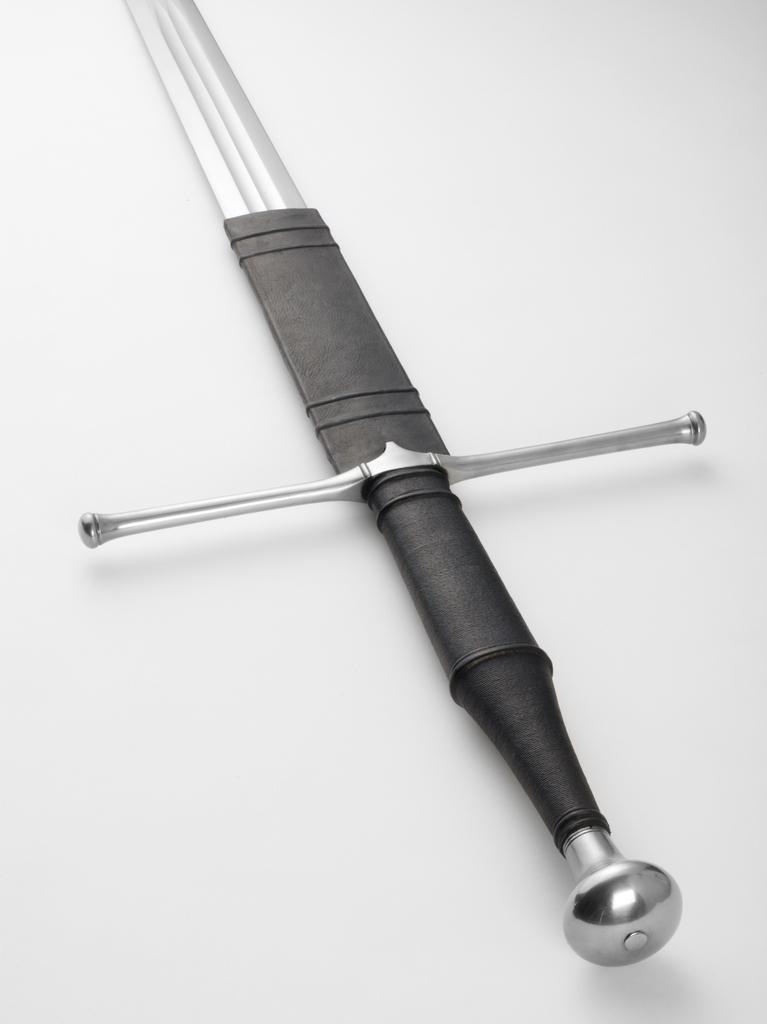Can you describe this image briefly? In the center of this picture we can see the blade, rain-guard, grip and a pommel of a sword. The background of the image is colored. 